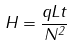Convert formula to latex. <formula><loc_0><loc_0><loc_500><loc_500>H = \frac { q L t } { N ^ { 2 } }</formula> 